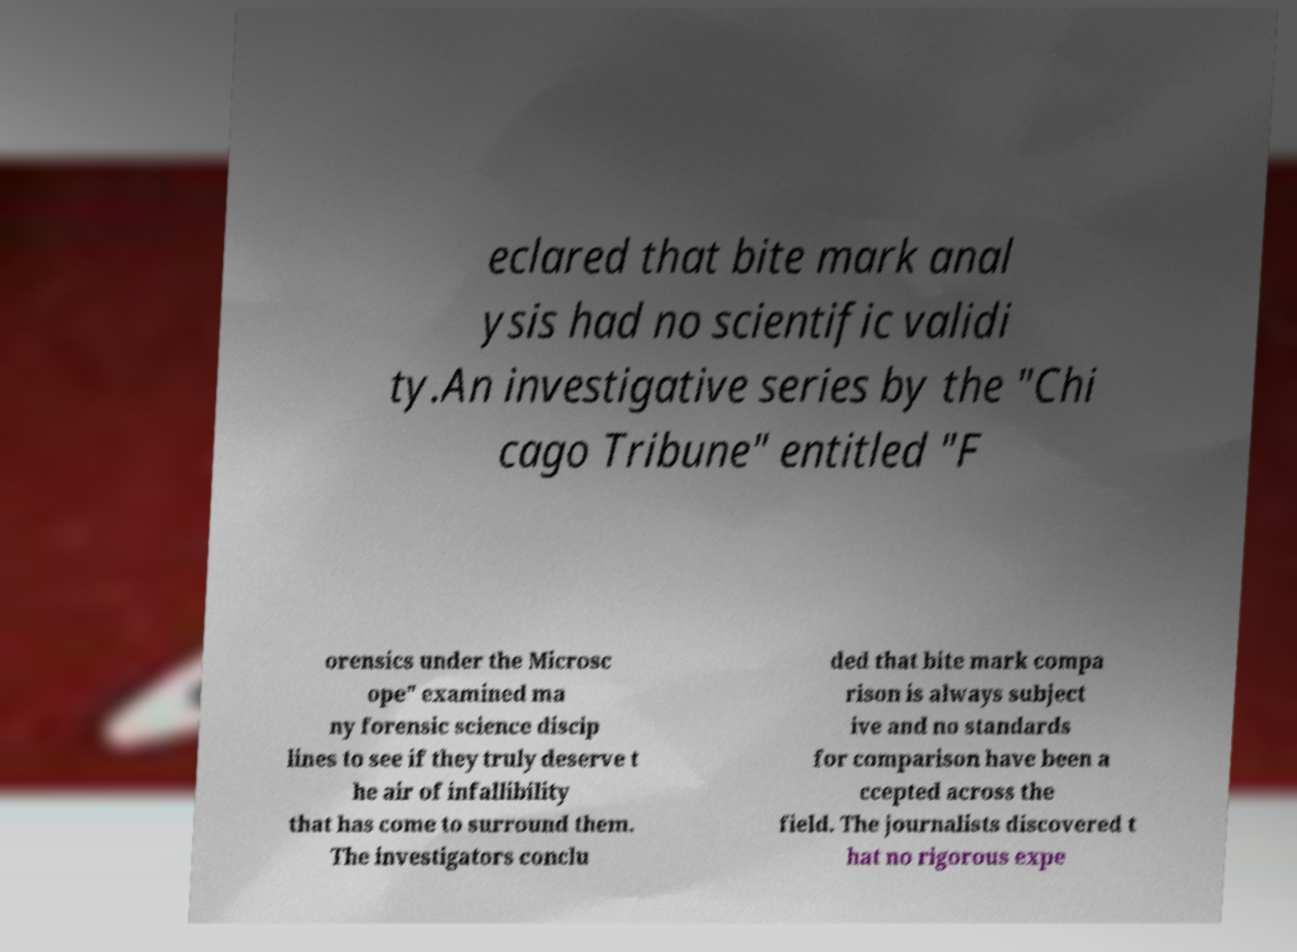I need the written content from this picture converted into text. Can you do that? eclared that bite mark anal ysis had no scientific validi ty.An investigative series by the "Chi cago Tribune" entitled "F orensics under the Microsc ope" examined ma ny forensic science discip lines to see if they truly deserve t he air of infallibility that has come to surround them. The investigators conclu ded that bite mark compa rison is always subject ive and no standards for comparison have been a ccepted across the field. The journalists discovered t hat no rigorous expe 